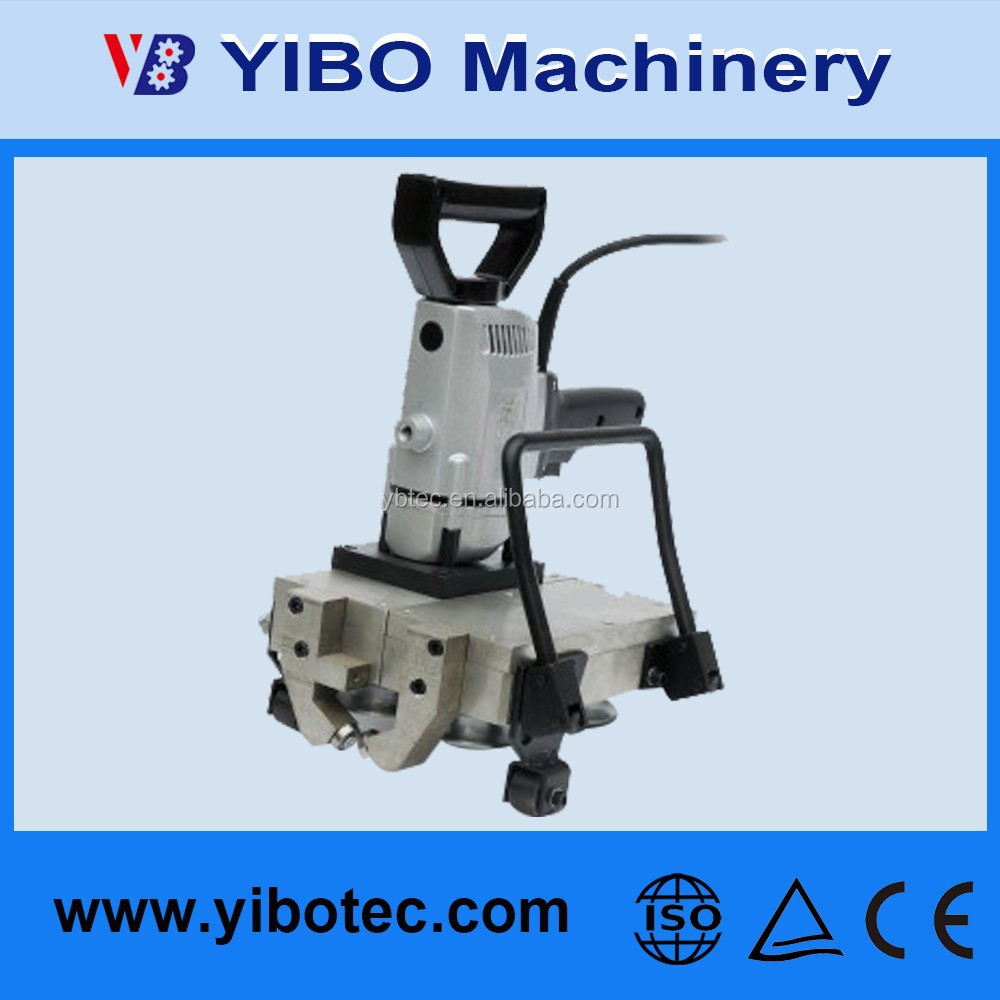If this machine could talk, what creative and imaginative story might it tell about its daily tasks and interactions? If this machine could talk, it would perhaps describe its days as a blend of precision and power, turning raw, unrefined materials into essential components for grand human creations. It might recount tales of transforming cold, rigid metal into the trusted arms of mighty machines or the intricate parts of everyday household appliances. It would explain its satisfaction in hearing the rhythmic hum of its engine, a sound resembling heartbeats, pounding away in a symphony of production. The machine might nostalgically remember the hands that felt slightly different from each operator, the careful settings adjusted for primary or complex tasks, and the occasional laughs or murmurs it overheard about the worker’s day. Now and then, it might mention replacing old and worn-out parts, which, while bittersweet, also meant it was renewed and ready for more tasks. In its imaginative narrative, it might embellish its environmental consciousness, enjoying the bustle of the assembly line and finding purpose in the never-ending flow of creation, upholding the legacy of its makers and delivering value, one precise cut at a time. 